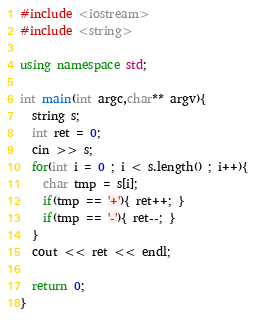Convert code to text. <code><loc_0><loc_0><loc_500><loc_500><_C++_>#include <iostream>
#include <string>

using namespace std;

int main(int argc,char** argv){
  string s;
  int ret = 0;
  cin >> s;
  for(int i = 0 ; i < s.length() ; i++){
    char tmp = s[i];
    if(tmp == '+'){ ret++; }
    if(tmp == '-'){ ret--; }
  }
  cout << ret << endl;

  return 0;
}
</code> 